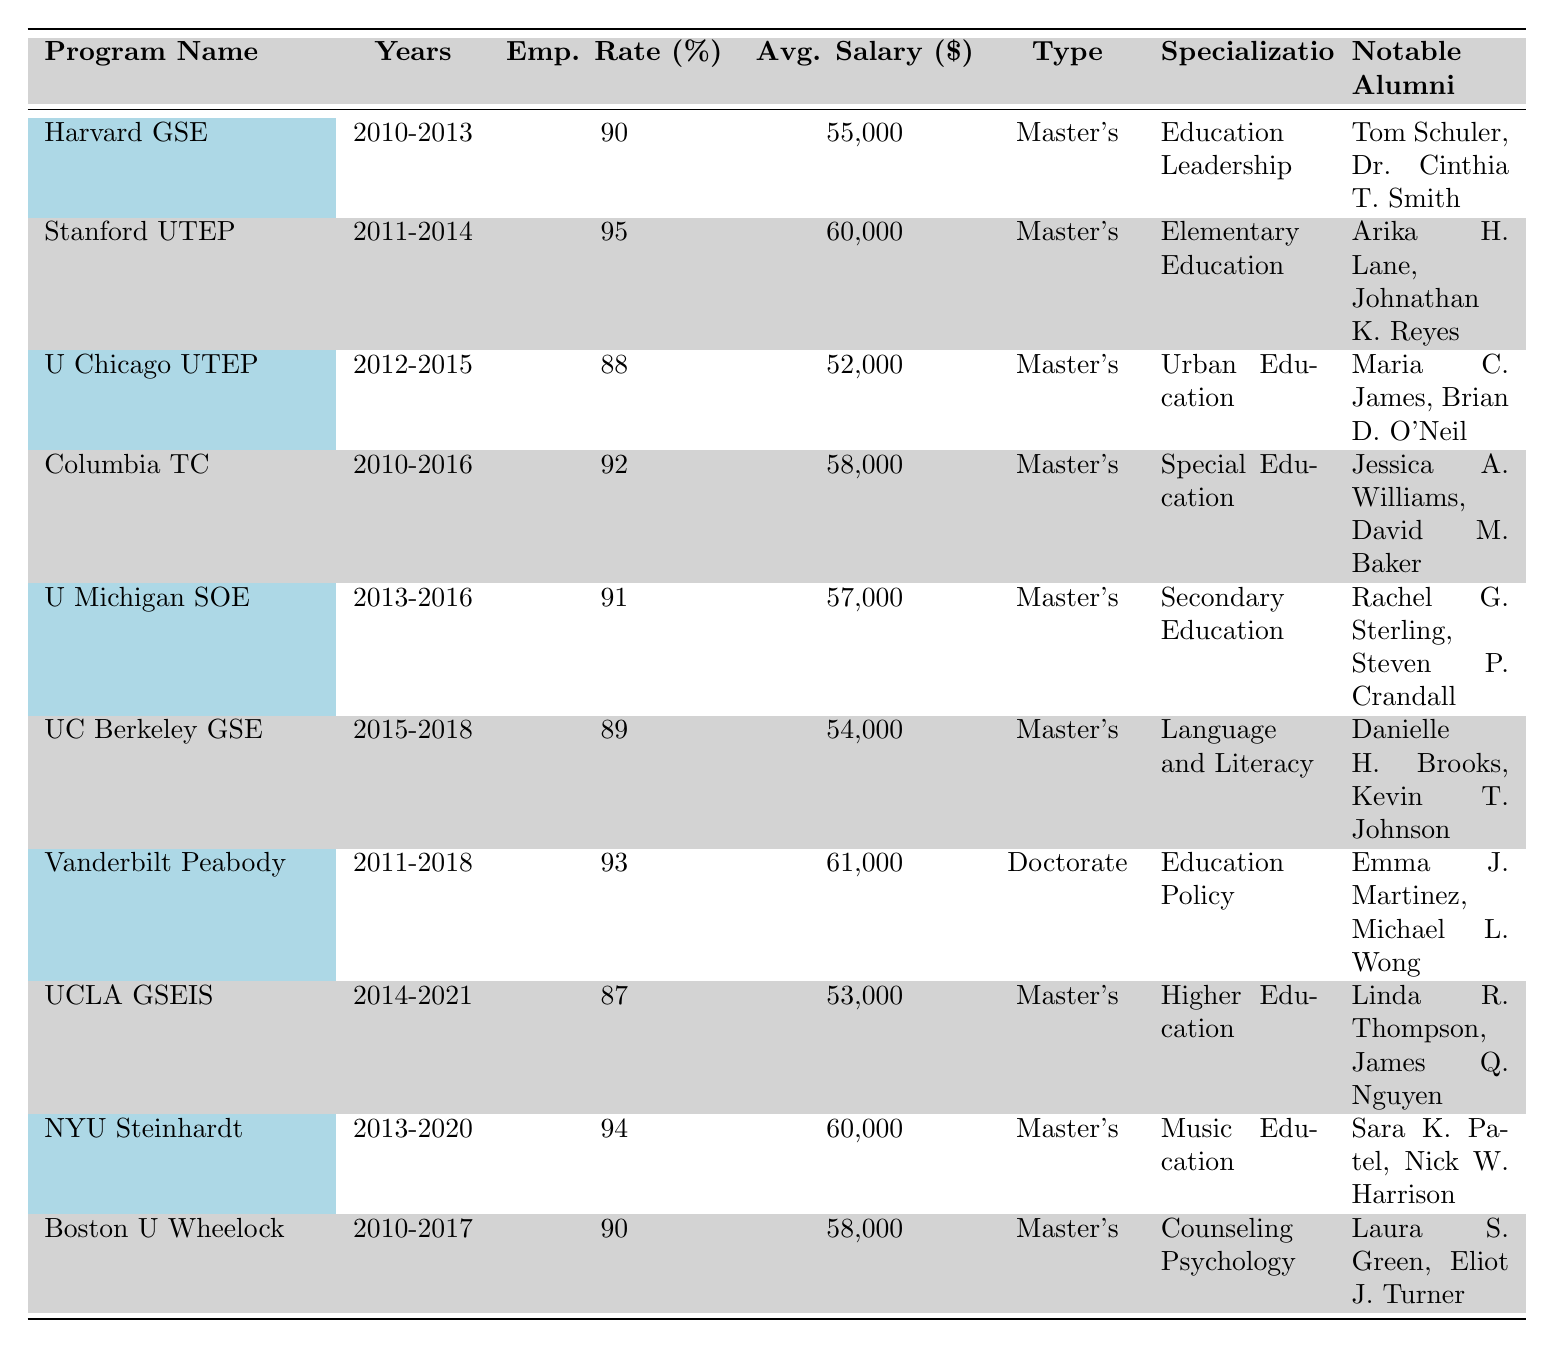What is the highest graduate employment rate among the programs listed? The graduate employment rates of the programs are 90%, 95%, 88%, 92%, 91%, 89%, 93%, 87%, 94%, and 90%. The highest is 95%, from the Stanford University Teacher Education Program.
Answer: 95% Which program has the lowest average salary post-graduation? The average salaries post-graduation are 55,000, 60,000, 52,000, 58,000, 57,000, 54,000, 61,000, 53,000, 60,000, and 58,000. The lowest is 52,000 from the University of Chicago Urban Teacher Education Program.
Answer: 52,000 Is there any program that specializes in Education Policy? The table indicates that Vanderbilt University Peabody College of Education specializes in Education Policy.
Answer: Yes How many programs have an employment rate of 90% or higher? The employment rates of the programs that are 90% or higher are 90%, 95%, 92%, 91%, 93%, and 94%, making a total of 6 programs.
Answer: 6 What is the average salary of programs with a specialization in Master's? The average salaries for Master's programs are 55,000, 60,000, 52,000, 58,000, 57,000, 54,000, 53,000, 60,000, and 58,000. The total salary is 55,000 + 60,000 + 52,000 + 58,000 + 57,000 + 54,000 + 53,000 + 60,000 + 58,000 =  454,000. Divided by 9 gives an average of 454,000 / 9 = 50,444.44, which rounds to 55,000.
Answer: 55,000 Is there anyone notable for their achievement in Music Education from NYU? Yes, notable alumni of the NYU Steinhardt School in Music Education include Sara K. Patel and Nick W. Harrison.
Answer: Yes Which program had the most years of operation listed? Looking at the "Years" column, the program with the longest duration is Columbia University's Teachers College, operating from 2010 to 2016, a total of 6 years.
Answer: 6 years What is the difference in average salaries between the program with the highest and the lowest salaries? The highest average salary is 61,000 from Vanderbilt University Peabody College, and the lowest is 52,000 from the University of Chicago UTEP. The difference is 61,000 - 52,000 = 9,000.
Answer: 9,000 Which university's program has the most notable alumni mentioned? Both Harvard Graduate School of Education and New York University Steinhardt School have two notable alumni each mentioned.
Answer: Harvard GSE and NYU Steinhardt Are there any programs that started in 2015 or later? Yes, the UC Berkeley Graduate School of Education started in 2015, and the University of California, Los Angeles (UCLA) started in 2014, both listed in the table.
Answer: Yes If we were to average the employment rates of all the programs, what would it be? The employment rates are 90%, 95%, 88%, 92%, 91%, 89%, 93%, 87%, 94%, and 90%. The total employment rate sum is 90 + 95 + 88 + 92 + 91 + 89 + 93 + 87 + 94 + 90 = 909. Dividing this by 10 gives an average of 909 / 10 = 90.9%.
Answer: 90.9% 